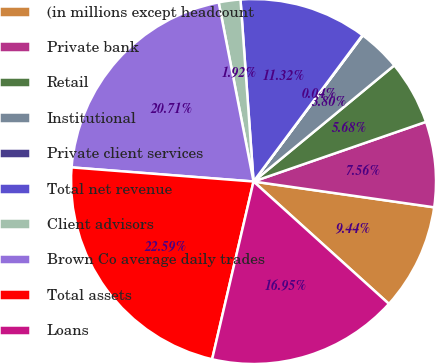Convert chart to OTSL. <chart><loc_0><loc_0><loc_500><loc_500><pie_chart><fcel>(in millions except headcount<fcel>Private bank<fcel>Retail<fcel>Institutional<fcel>Private client services<fcel>Total net revenue<fcel>Client advisors<fcel>Brown Co average daily trades<fcel>Total assets<fcel>Loans<nl><fcel>9.44%<fcel>7.56%<fcel>5.68%<fcel>3.8%<fcel>0.04%<fcel>11.32%<fcel>1.92%<fcel>20.71%<fcel>22.59%<fcel>16.95%<nl></chart> 